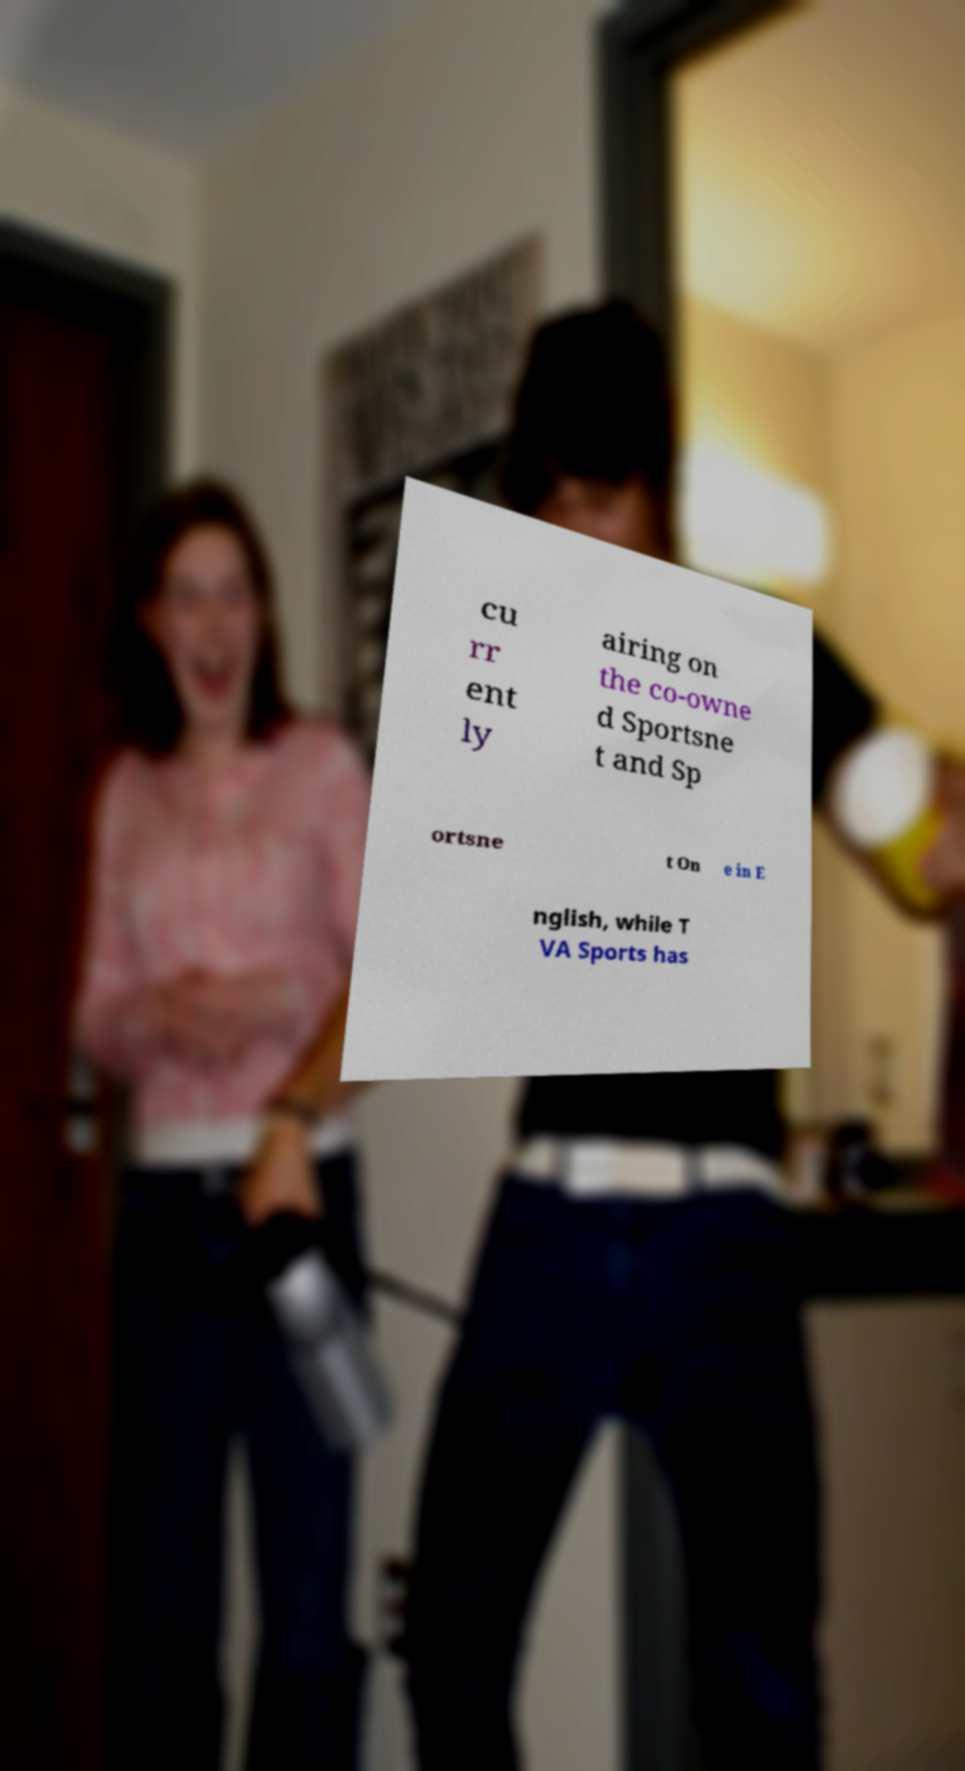I need the written content from this picture converted into text. Can you do that? cu rr ent ly airing on the co-owne d Sportsne t and Sp ortsne t On e in E nglish, while T VA Sports has 